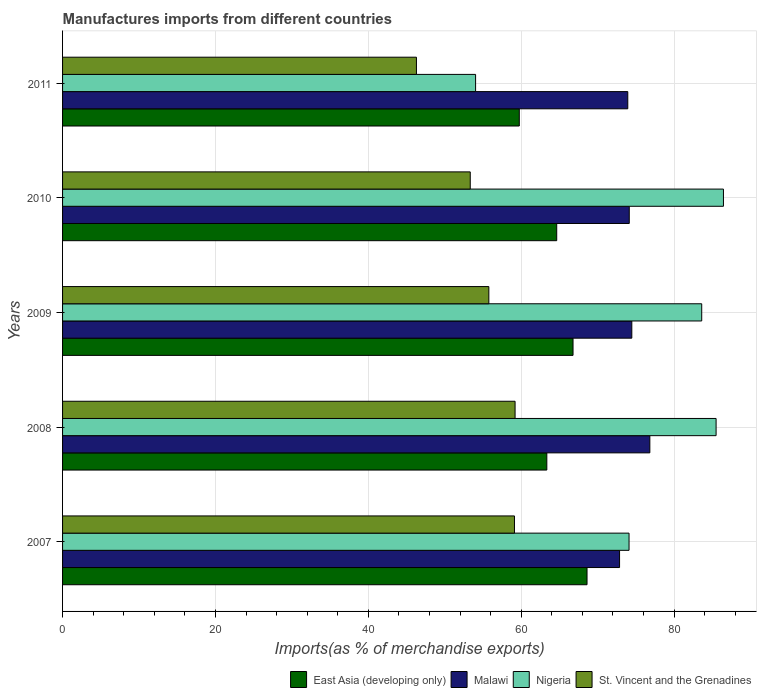Are the number of bars per tick equal to the number of legend labels?
Ensure brevity in your answer.  Yes. How many bars are there on the 2nd tick from the top?
Offer a very short reply. 4. How many bars are there on the 2nd tick from the bottom?
Provide a short and direct response. 4. What is the label of the 1st group of bars from the top?
Keep it short and to the point. 2011. In how many cases, is the number of bars for a given year not equal to the number of legend labels?
Provide a short and direct response. 0. What is the percentage of imports to different countries in Malawi in 2011?
Keep it short and to the point. 73.94. Across all years, what is the maximum percentage of imports to different countries in Nigeria?
Your answer should be very brief. 86.45. Across all years, what is the minimum percentage of imports to different countries in Malawi?
Your answer should be very brief. 72.86. In which year was the percentage of imports to different countries in St. Vincent and the Grenadines maximum?
Your response must be concise. 2008. In which year was the percentage of imports to different countries in East Asia (developing only) minimum?
Ensure brevity in your answer.  2011. What is the total percentage of imports to different countries in Malawi in the graph?
Your response must be concise. 372.21. What is the difference between the percentage of imports to different countries in Malawi in 2009 and that in 2011?
Provide a short and direct response. 0.53. What is the difference between the percentage of imports to different countries in Nigeria in 2010 and the percentage of imports to different countries in Malawi in 2007?
Ensure brevity in your answer.  13.59. What is the average percentage of imports to different countries in Malawi per year?
Provide a short and direct response. 74.44. In the year 2009, what is the difference between the percentage of imports to different countries in East Asia (developing only) and percentage of imports to different countries in Nigeria?
Make the answer very short. -16.83. In how many years, is the percentage of imports to different countries in East Asia (developing only) greater than 72 %?
Offer a very short reply. 0. What is the ratio of the percentage of imports to different countries in St. Vincent and the Grenadines in 2008 to that in 2010?
Make the answer very short. 1.11. Is the percentage of imports to different countries in East Asia (developing only) in 2007 less than that in 2011?
Provide a short and direct response. No. Is the difference between the percentage of imports to different countries in East Asia (developing only) in 2007 and 2008 greater than the difference between the percentage of imports to different countries in Nigeria in 2007 and 2008?
Offer a very short reply. Yes. What is the difference between the highest and the second highest percentage of imports to different countries in East Asia (developing only)?
Your response must be concise. 1.83. What is the difference between the highest and the lowest percentage of imports to different countries in Nigeria?
Make the answer very short. 32.42. Is the sum of the percentage of imports to different countries in East Asia (developing only) in 2008 and 2011 greater than the maximum percentage of imports to different countries in St. Vincent and the Grenadines across all years?
Your response must be concise. Yes. Is it the case that in every year, the sum of the percentage of imports to different countries in Malawi and percentage of imports to different countries in East Asia (developing only) is greater than the sum of percentage of imports to different countries in Nigeria and percentage of imports to different countries in St. Vincent and the Grenadines?
Offer a very short reply. No. What does the 1st bar from the top in 2010 represents?
Your answer should be very brief. St. Vincent and the Grenadines. What does the 1st bar from the bottom in 2011 represents?
Make the answer very short. East Asia (developing only). Is it the case that in every year, the sum of the percentage of imports to different countries in East Asia (developing only) and percentage of imports to different countries in Malawi is greater than the percentage of imports to different countries in Nigeria?
Offer a very short reply. Yes. Are all the bars in the graph horizontal?
Give a very brief answer. Yes. Are the values on the major ticks of X-axis written in scientific E-notation?
Provide a succinct answer. No. Does the graph contain any zero values?
Give a very brief answer. No. Does the graph contain grids?
Provide a succinct answer. Yes. How many legend labels are there?
Your response must be concise. 4. What is the title of the graph?
Your answer should be compact. Manufactures imports from different countries. Does "Croatia" appear as one of the legend labels in the graph?
Ensure brevity in your answer.  No. What is the label or title of the X-axis?
Your answer should be very brief. Imports(as % of merchandise exports). What is the label or title of the Y-axis?
Ensure brevity in your answer.  Years. What is the Imports(as % of merchandise exports) in East Asia (developing only) in 2007?
Provide a succinct answer. 68.6. What is the Imports(as % of merchandise exports) of Malawi in 2007?
Give a very brief answer. 72.86. What is the Imports(as % of merchandise exports) in Nigeria in 2007?
Offer a very short reply. 74.1. What is the Imports(as % of merchandise exports) in St. Vincent and the Grenadines in 2007?
Provide a short and direct response. 59.11. What is the Imports(as % of merchandise exports) in East Asia (developing only) in 2008?
Ensure brevity in your answer.  63.35. What is the Imports(as % of merchandise exports) of Malawi in 2008?
Ensure brevity in your answer.  76.82. What is the Imports(as % of merchandise exports) of Nigeria in 2008?
Your answer should be compact. 85.49. What is the Imports(as % of merchandise exports) in St. Vincent and the Grenadines in 2008?
Offer a terse response. 59.19. What is the Imports(as % of merchandise exports) in East Asia (developing only) in 2009?
Give a very brief answer. 66.77. What is the Imports(as % of merchandise exports) in Malawi in 2009?
Your answer should be compact. 74.46. What is the Imports(as % of merchandise exports) of Nigeria in 2009?
Offer a very short reply. 83.61. What is the Imports(as % of merchandise exports) in St. Vincent and the Grenadines in 2009?
Give a very brief answer. 55.76. What is the Imports(as % of merchandise exports) of East Asia (developing only) in 2010?
Keep it short and to the point. 64.64. What is the Imports(as % of merchandise exports) in Malawi in 2010?
Give a very brief answer. 74.13. What is the Imports(as % of merchandise exports) in Nigeria in 2010?
Offer a very short reply. 86.45. What is the Imports(as % of merchandise exports) of St. Vincent and the Grenadines in 2010?
Make the answer very short. 53.33. What is the Imports(as % of merchandise exports) in East Asia (developing only) in 2011?
Offer a terse response. 59.74. What is the Imports(as % of merchandise exports) in Malawi in 2011?
Give a very brief answer. 73.94. What is the Imports(as % of merchandise exports) of Nigeria in 2011?
Provide a short and direct response. 54.03. What is the Imports(as % of merchandise exports) of St. Vincent and the Grenadines in 2011?
Ensure brevity in your answer.  46.29. Across all years, what is the maximum Imports(as % of merchandise exports) of East Asia (developing only)?
Provide a short and direct response. 68.6. Across all years, what is the maximum Imports(as % of merchandise exports) of Malawi?
Provide a succinct answer. 76.82. Across all years, what is the maximum Imports(as % of merchandise exports) of Nigeria?
Keep it short and to the point. 86.45. Across all years, what is the maximum Imports(as % of merchandise exports) of St. Vincent and the Grenadines?
Offer a terse response. 59.19. Across all years, what is the minimum Imports(as % of merchandise exports) of East Asia (developing only)?
Make the answer very short. 59.74. Across all years, what is the minimum Imports(as % of merchandise exports) of Malawi?
Your answer should be compact. 72.86. Across all years, what is the minimum Imports(as % of merchandise exports) in Nigeria?
Give a very brief answer. 54.03. Across all years, what is the minimum Imports(as % of merchandise exports) in St. Vincent and the Grenadines?
Your response must be concise. 46.29. What is the total Imports(as % of merchandise exports) in East Asia (developing only) in the graph?
Your answer should be very brief. 323.11. What is the total Imports(as % of merchandise exports) in Malawi in the graph?
Give a very brief answer. 372.21. What is the total Imports(as % of merchandise exports) of Nigeria in the graph?
Ensure brevity in your answer.  383.67. What is the total Imports(as % of merchandise exports) of St. Vincent and the Grenadines in the graph?
Offer a very short reply. 273.69. What is the difference between the Imports(as % of merchandise exports) of East Asia (developing only) in 2007 and that in 2008?
Your answer should be compact. 5.26. What is the difference between the Imports(as % of merchandise exports) in Malawi in 2007 and that in 2008?
Your answer should be very brief. -3.96. What is the difference between the Imports(as % of merchandise exports) in Nigeria in 2007 and that in 2008?
Give a very brief answer. -11.39. What is the difference between the Imports(as % of merchandise exports) of St. Vincent and the Grenadines in 2007 and that in 2008?
Your answer should be compact. -0.08. What is the difference between the Imports(as % of merchandise exports) in East Asia (developing only) in 2007 and that in 2009?
Provide a succinct answer. 1.83. What is the difference between the Imports(as % of merchandise exports) of Malawi in 2007 and that in 2009?
Your answer should be compact. -1.6. What is the difference between the Imports(as % of merchandise exports) in Nigeria in 2007 and that in 2009?
Offer a very short reply. -9.51. What is the difference between the Imports(as % of merchandise exports) of St. Vincent and the Grenadines in 2007 and that in 2009?
Your answer should be very brief. 3.35. What is the difference between the Imports(as % of merchandise exports) of East Asia (developing only) in 2007 and that in 2010?
Your answer should be compact. 3.96. What is the difference between the Imports(as % of merchandise exports) of Malawi in 2007 and that in 2010?
Your answer should be very brief. -1.27. What is the difference between the Imports(as % of merchandise exports) of Nigeria in 2007 and that in 2010?
Keep it short and to the point. -12.35. What is the difference between the Imports(as % of merchandise exports) of St. Vincent and the Grenadines in 2007 and that in 2010?
Offer a very short reply. 5.78. What is the difference between the Imports(as % of merchandise exports) of East Asia (developing only) in 2007 and that in 2011?
Provide a succinct answer. 8.86. What is the difference between the Imports(as % of merchandise exports) in Malawi in 2007 and that in 2011?
Make the answer very short. -1.08. What is the difference between the Imports(as % of merchandise exports) of Nigeria in 2007 and that in 2011?
Your response must be concise. 20.07. What is the difference between the Imports(as % of merchandise exports) in St. Vincent and the Grenadines in 2007 and that in 2011?
Your response must be concise. 12.82. What is the difference between the Imports(as % of merchandise exports) in East Asia (developing only) in 2008 and that in 2009?
Give a very brief answer. -3.43. What is the difference between the Imports(as % of merchandise exports) of Malawi in 2008 and that in 2009?
Your answer should be very brief. 2.36. What is the difference between the Imports(as % of merchandise exports) in Nigeria in 2008 and that in 2009?
Your answer should be very brief. 1.88. What is the difference between the Imports(as % of merchandise exports) of St. Vincent and the Grenadines in 2008 and that in 2009?
Ensure brevity in your answer.  3.43. What is the difference between the Imports(as % of merchandise exports) in East Asia (developing only) in 2008 and that in 2010?
Offer a terse response. -1.29. What is the difference between the Imports(as % of merchandise exports) in Malawi in 2008 and that in 2010?
Your response must be concise. 2.69. What is the difference between the Imports(as % of merchandise exports) of Nigeria in 2008 and that in 2010?
Offer a very short reply. -0.96. What is the difference between the Imports(as % of merchandise exports) in St. Vincent and the Grenadines in 2008 and that in 2010?
Provide a short and direct response. 5.86. What is the difference between the Imports(as % of merchandise exports) of East Asia (developing only) in 2008 and that in 2011?
Provide a short and direct response. 3.6. What is the difference between the Imports(as % of merchandise exports) in Malawi in 2008 and that in 2011?
Your response must be concise. 2.89. What is the difference between the Imports(as % of merchandise exports) in Nigeria in 2008 and that in 2011?
Make the answer very short. 31.46. What is the difference between the Imports(as % of merchandise exports) of St. Vincent and the Grenadines in 2008 and that in 2011?
Provide a short and direct response. 12.9. What is the difference between the Imports(as % of merchandise exports) of East Asia (developing only) in 2009 and that in 2010?
Ensure brevity in your answer.  2.13. What is the difference between the Imports(as % of merchandise exports) of Malawi in 2009 and that in 2010?
Make the answer very short. 0.33. What is the difference between the Imports(as % of merchandise exports) in Nigeria in 2009 and that in 2010?
Give a very brief answer. -2.84. What is the difference between the Imports(as % of merchandise exports) in St. Vincent and the Grenadines in 2009 and that in 2010?
Ensure brevity in your answer.  2.43. What is the difference between the Imports(as % of merchandise exports) in East Asia (developing only) in 2009 and that in 2011?
Your answer should be compact. 7.03. What is the difference between the Imports(as % of merchandise exports) of Malawi in 2009 and that in 2011?
Offer a very short reply. 0.53. What is the difference between the Imports(as % of merchandise exports) of Nigeria in 2009 and that in 2011?
Keep it short and to the point. 29.58. What is the difference between the Imports(as % of merchandise exports) in St. Vincent and the Grenadines in 2009 and that in 2011?
Keep it short and to the point. 9.47. What is the difference between the Imports(as % of merchandise exports) of East Asia (developing only) in 2010 and that in 2011?
Your answer should be compact. 4.9. What is the difference between the Imports(as % of merchandise exports) in Malawi in 2010 and that in 2011?
Offer a terse response. 0.19. What is the difference between the Imports(as % of merchandise exports) of Nigeria in 2010 and that in 2011?
Offer a terse response. 32.42. What is the difference between the Imports(as % of merchandise exports) of St. Vincent and the Grenadines in 2010 and that in 2011?
Your answer should be compact. 7.04. What is the difference between the Imports(as % of merchandise exports) in East Asia (developing only) in 2007 and the Imports(as % of merchandise exports) in Malawi in 2008?
Keep it short and to the point. -8.22. What is the difference between the Imports(as % of merchandise exports) of East Asia (developing only) in 2007 and the Imports(as % of merchandise exports) of Nigeria in 2008?
Give a very brief answer. -16.88. What is the difference between the Imports(as % of merchandise exports) in East Asia (developing only) in 2007 and the Imports(as % of merchandise exports) in St. Vincent and the Grenadines in 2008?
Your response must be concise. 9.41. What is the difference between the Imports(as % of merchandise exports) of Malawi in 2007 and the Imports(as % of merchandise exports) of Nigeria in 2008?
Keep it short and to the point. -12.63. What is the difference between the Imports(as % of merchandise exports) in Malawi in 2007 and the Imports(as % of merchandise exports) in St. Vincent and the Grenadines in 2008?
Make the answer very short. 13.67. What is the difference between the Imports(as % of merchandise exports) of Nigeria in 2007 and the Imports(as % of merchandise exports) of St. Vincent and the Grenadines in 2008?
Give a very brief answer. 14.91. What is the difference between the Imports(as % of merchandise exports) in East Asia (developing only) in 2007 and the Imports(as % of merchandise exports) in Malawi in 2009?
Your answer should be compact. -5.86. What is the difference between the Imports(as % of merchandise exports) in East Asia (developing only) in 2007 and the Imports(as % of merchandise exports) in Nigeria in 2009?
Give a very brief answer. -15. What is the difference between the Imports(as % of merchandise exports) in East Asia (developing only) in 2007 and the Imports(as % of merchandise exports) in St. Vincent and the Grenadines in 2009?
Give a very brief answer. 12.84. What is the difference between the Imports(as % of merchandise exports) in Malawi in 2007 and the Imports(as % of merchandise exports) in Nigeria in 2009?
Make the answer very short. -10.75. What is the difference between the Imports(as % of merchandise exports) in Malawi in 2007 and the Imports(as % of merchandise exports) in St. Vincent and the Grenadines in 2009?
Provide a short and direct response. 17.1. What is the difference between the Imports(as % of merchandise exports) of Nigeria in 2007 and the Imports(as % of merchandise exports) of St. Vincent and the Grenadines in 2009?
Ensure brevity in your answer.  18.34. What is the difference between the Imports(as % of merchandise exports) in East Asia (developing only) in 2007 and the Imports(as % of merchandise exports) in Malawi in 2010?
Provide a short and direct response. -5.52. What is the difference between the Imports(as % of merchandise exports) in East Asia (developing only) in 2007 and the Imports(as % of merchandise exports) in Nigeria in 2010?
Your response must be concise. -17.85. What is the difference between the Imports(as % of merchandise exports) in East Asia (developing only) in 2007 and the Imports(as % of merchandise exports) in St. Vincent and the Grenadines in 2010?
Provide a short and direct response. 15.28. What is the difference between the Imports(as % of merchandise exports) in Malawi in 2007 and the Imports(as % of merchandise exports) in Nigeria in 2010?
Offer a terse response. -13.59. What is the difference between the Imports(as % of merchandise exports) in Malawi in 2007 and the Imports(as % of merchandise exports) in St. Vincent and the Grenadines in 2010?
Offer a terse response. 19.53. What is the difference between the Imports(as % of merchandise exports) in Nigeria in 2007 and the Imports(as % of merchandise exports) in St. Vincent and the Grenadines in 2010?
Your response must be concise. 20.77. What is the difference between the Imports(as % of merchandise exports) of East Asia (developing only) in 2007 and the Imports(as % of merchandise exports) of Malawi in 2011?
Your answer should be compact. -5.33. What is the difference between the Imports(as % of merchandise exports) of East Asia (developing only) in 2007 and the Imports(as % of merchandise exports) of Nigeria in 2011?
Your answer should be very brief. 14.58. What is the difference between the Imports(as % of merchandise exports) of East Asia (developing only) in 2007 and the Imports(as % of merchandise exports) of St. Vincent and the Grenadines in 2011?
Provide a short and direct response. 22.31. What is the difference between the Imports(as % of merchandise exports) of Malawi in 2007 and the Imports(as % of merchandise exports) of Nigeria in 2011?
Provide a short and direct response. 18.83. What is the difference between the Imports(as % of merchandise exports) of Malawi in 2007 and the Imports(as % of merchandise exports) of St. Vincent and the Grenadines in 2011?
Make the answer very short. 26.57. What is the difference between the Imports(as % of merchandise exports) of Nigeria in 2007 and the Imports(as % of merchandise exports) of St. Vincent and the Grenadines in 2011?
Keep it short and to the point. 27.81. What is the difference between the Imports(as % of merchandise exports) in East Asia (developing only) in 2008 and the Imports(as % of merchandise exports) in Malawi in 2009?
Your response must be concise. -11.12. What is the difference between the Imports(as % of merchandise exports) of East Asia (developing only) in 2008 and the Imports(as % of merchandise exports) of Nigeria in 2009?
Make the answer very short. -20.26. What is the difference between the Imports(as % of merchandise exports) of East Asia (developing only) in 2008 and the Imports(as % of merchandise exports) of St. Vincent and the Grenadines in 2009?
Ensure brevity in your answer.  7.58. What is the difference between the Imports(as % of merchandise exports) in Malawi in 2008 and the Imports(as % of merchandise exports) in Nigeria in 2009?
Your answer should be compact. -6.78. What is the difference between the Imports(as % of merchandise exports) of Malawi in 2008 and the Imports(as % of merchandise exports) of St. Vincent and the Grenadines in 2009?
Provide a short and direct response. 21.06. What is the difference between the Imports(as % of merchandise exports) of Nigeria in 2008 and the Imports(as % of merchandise exports) of St. Vincent and the Grenadines in 2009?
Provide a short and direct response. 29.73. What is the difference between the Imports(as % of merchandise exports) in East Asia (developing only) in 2008 and the Imports(as % of merchandise exports) in Malawi in 2010?
Offer a terse response. -10.78. What is the difference between the Imports(as % of merchandise exports) in East Asia (developing only) in 2008 and the Imports(as % of merchandise exports) in Nigeria in 2010?
Keep it short and to the point. -23.1. What is the difference between the Imports(as % of merchandise exports) in East Asia (developing only) in 2008 and the Imports(as % of merchandise exports) in St. Vincent and the Grenadines in 2010?
Your answer should be compact. 10.02. What is the difference between the Imports(as % of merchandise exports) of Malawi in 2008 and the Imports(as % of merchandise exports) of Nigeria in 2010?
Ensure brevity in your answer.  -9.63. What is the difference between the Imports(as % of merchandise exports) in Malawi in 2008 and the Imports(as % of merchandise exports) in St. Vincent and the Grenadines in 2010?
Your answer should be very brief. 23.49. What is the difference between the Imports(as % of merchandise exports) of Nigeria in 2008 and the Imports(as % of merchandise exports) of St. Vincent and the Grenadines in 2010?
Give a very brief answer. 32.16. What is the difference between the Imports(as % of merchandise exports) of East Asia (developing only) in 2008 and the Imports(as % of merchandise exports) of Malawi in 2011?
Offer a very short reply. -10.59. What is the difference between the Imports(as % of merchandise exports) in East Asia (developing only) in 2008 and the Imports(as % of merchandise exports) in Nigeria in 2011?
Offer a terse response. 9.32. What is the difference between the Imports(as % of merchandise exports) in East Asia (developing only) in 2008 and the Imports(as % of merchandise exports) in St. Vincent and the Grenadines in 2011?
Give a very brief answer. 17.06. What is the difference between the Imports(as % of merchandise exports) in Malawi in 2008 and the Imports(as % of merchandise exports) in Nigeria in 2011?
Make the answer very short. 22.79. What is the difference between the Imports(as % of merchandise exports) of Malawi in 2008 and the Imports(as % of merchandise exports) of St. Vincent and the Grenadines in 2011?
Provide a succinct answer. 30.53. What is the difference between the Imports(as % of merchandise exports) in Nigeria in 2008 and the Imports(as % of merchandise exports) in St. Vincent and the Grenadines in 2011?
Your answer should be very brief. 39.2. What is the difference between the Imports(as % of merchandise exports) of East Asia (developing only) in 2009 and the Imports(as % of merchandise exports) of Malawi in 2010?
Give a very brief answer. -7.35. What is the difference between the Imports(as % of merchandise exports) of East Asia (developing only) in 2009 and the Imports(as % of merchandise exports) of Nigeria in 2010?
Provide a succinct answer. -19.68. What is the difference between the Imports(as % of merchandise exports) in East Asia (developing only) in 2009 and the Imports(as % of merchandise exports) in St. Vincent and the Grenadines in 2010?
Ensure brevity in your answer.  13.45. What is the difference between the Imports(as % of merchandise exports) of Malawi in 2009 and the Imports(as % of merchandise exports) of Nigeria in 2010?
Provide a short and direct response. -11.99. What is the difference between the Imports(as % of merchandise exports) in Malawi in 2009 and the Imports(as % of merchandise exports) in St. Vincent and the Grenadines in 2010?
Offer a very short reply. 21.13. What is the difference between the Imports(as % of merchandise exports) of Nigeria in 2009 and the Imports(as % of merchandise exports) of St. Vincent and the Grenadines in 2010?
Keep it short and to the point. 30.28. What is the difference between the Imports(as % of merchandise exports) in East Asia (developing only) in 2009 and the Imports(as % of merchandise exports) in Malawi in 2011?
Offer a very short reply. -7.16. What is the difference between the Imports(as % of merchandise exports) of East Asia (developing only) in 2009 and the Imports(as % of merchandise exports) of Nigeria in 2011?
Make the answer very short. 12.75. What is the difference between the Imports(as % of merchandise exports) of East Asia (developing only) in 2009 and the Imports(as % of merchandise exports) of St. Vincent and the Grenadines in 2011?
Give a very brief answer. 20.48. What is the difference between the Imports(as % of merchandise exports) in Malawi in 2009 and the Imports(as % of merchandise exports) in Nigeria in 2011?
Your answer should be compact. 20.43. What is the difference between the Imports(as % of merchandise exports) of Malawi in 2009 and the Imports(as % of merchandise exports) of St. Vincent and the Grenadines in 2011?
Your response must be concise. 28.17. What is the difference between the Imports(as % of merchandise exports) of Nigeria in 2009 and the Imports(as % of merchandise exports) of St. Vincent and the Grenadines in 2011?
Provide a short and direct response. 37.32. What is the difference between the Imports(as % of merchandise exports) in East Asia (developing only) in 2010 and the Imports(as % of merchandise exports) in Malawi in 2011?
Your response must be concise. -9.3. What is the difference between the Imports(as % of merchandise exports) in East Asia (developing only) in 2010 and the Imports(as % of merchandise exports) in Nigeria in 2011?
Ensure brevity in your answer.  10.61. What is the difference between the Imports(as % of merchandise exports) of East Asia (developing only) in 2010 and the Imports(as % of merchandise exports) of St. Vincent and the Grenadines in 2011?
Offer a terse response. 18.35. What is the difference between the Imports(as % of merchandise exports) of Malawi in 2010 and the Imports(as % of merchandise exports) of Nigeria in 2011?
Provide a succinct answer. 20.1. What is the difference between the Imports(as % of merchandise exports) of Malawi in 2010 and the Imports(as % of merchandise exports) of St. Vincent and the Grenadines in 2011?
Give a very brief answer. 27.84. What is the difference between the Imports(as % of merchandise exports) in Nigeria in 2010 and the Imports(as % of merchandise exports) in St. Vincent and the Grenadines in 2011?
Your response must be concise. 40.16. What is the average Imports(as % of merchandise exports) of East Asia (developing only) per year?
Provide a short and direct response. 64.62. What is the average Imports(as % of merchandise exports) in Malawi per year?
Offer a terse response. 74.44. What is the average Imports(as % of merchandise exports) of Nigeria per year?
Provide a short and direct response. 76.73. What is the average Imports(as % of merchandise exports) of St. Vincent and the Grenadines per year?
Ensure brevity in your answer.  54.74. In the year 2007, what is the difference between the Imports(as % of merchandise exports) in East Asia (developing only) and Imports(as % of merchandise exports) in Malawi?
Make the answer very short. -4.26. In the year 2007, what is the difference between the Imports(as % of merchandise exports) in East Asia (developing only) and Imports(as % of merchandise exports) in Nigeria?
Keep it short and to the point. -5.5. In the year 2007, what is the difference between the Imports(as % of merchandise exports) in East Asia (developing only) and Imports(as % of merchandise exports) in St. Vincent and the Grenadines?
Your response must be concise. 9.49. In the year 2007, what is the difference between the Imports(as % of merchandise exports) in Malawi and Imports(as % of merchandise exports) in Nigeria?
Your response must be concise. -1.24. In the year 2007, what is the difference between the Imports(as % of merchandise exports) in Malawi and Imports(as % of merchandise exports) in St. Vincent and the Grenadines?
Keep it short and to the point. 13.75. In the year 2007, what is the difference between the Imports(as % of merchandise exports) in Nigeria and Imports(as % of merchandise exports) in St. Vincent and the Grenadines?
Make the answer very short. 14.99. In the year 2008, what is the difference between the Imports(as % of merchandise exports) of East Asia (developing only) and Imports(as % of merchandise exports) of Malawi?
Provide a short and direct response. -13.48. In the year 2008, what is the difference between the Imports(as % of merchandise exports) in East Asia (developing only) and Imports(as % of merchandise exports) in Nigeria?
Offer a very short reply. -22.14. In the year 2008, what is the difference between the Imports(as % of merchandise exports) in East Asia (developing only) and Imports(as % of merchandise exports) in St. Vincent and the Grenadines?
Your answer should be compact. 4.15. In the year 2008, what is the difference between the Imports(as % of merchandise exports) of Malawi and Imports(as % of merchandise exports) of Nigeria?
Your answer should be very brief. -8.67. In the year 2008, what is the difference between the Imports(as % of merchandise exports) in Malawi and Imports(as % of merchandise exports) in St. Vincent and the Grenadines?
Offer a terse response. 17.63. In the year 2008, what is the difference between the Imports(as % of merchandise exports) of Nigeria and Imports(as % of merchandise exports) of St. Vincent and the Grenadines?
Keep it short and to the point. 26.29. In the year 2009, what is the difference between the Imports(as % of merchandise exports) in East Asia (developing only) and Imports(as % of merchandise exports) in Malawi?
Your answer should be very brief. -7.69. In the year 2009, what is the difference between the Imports(as % of merchandise exports) of East Asia (developing only) and Imports(as % of merchandise exports) of Nigeria?
Your response must be concise. -16.83. In the year 2009, what is the difference between the Imports(as % of merchandise exports) in East Asia (developing only) and Imports(as % of merchandise exports) in St. Vincent and the Grenadines?
Ensure brevity in your answer.  11.01. In the year 2009, what is the difference between the Imports(as % of merchandise exports) in Malawi and Imports(as % of merchandise exports) in Nigeria?
Provide a short and direct response. -9.14. In the year 2009, what is the difference between the Imports(as % of merchandise exports) of Malawi and Imports(as % of merchandise exports) of St. Vincent and the Grenadines?
Give a very brief answer. 18.7. In the year 2009, what is the difference between the Imports(as % of merchandise exports) in Nigeria and Imports(as % of merchandise exports) in St. Vincent and the Grenadines?
Your answer should be compact. 27.85. In the year 2010, what is the difference between the Imports(as % of merchandise exports) in East Asia (developing only) and Imports(as % of merchandise exports) in Malawi?
Your response must be concise. -9.49. In the year 2010, what is the difference between the Imports(as % of merchandise exports) in East Asia (developing only) and Imports(as % of merchandise exports) in Nigeria?
Your answer should be compact. -21.81. In the year 2010, what is the difference between the Imports(as % of merchandise exports) in East Asia (developing only) and Imports(as % of merchandise exports) in St. Vincent and the Grenadines?
Provide a short and direct response. 11.31. In the year 2010, what is the difference between the Imports(as % of merchandise exports) in Malawi and Imports(as % of merchandise exports) in Nigeria?
Provide a succinct answer. -12.32. In the year 2010, what is the difference between the Imports(as % of merchandise exports) of Malawi and Imports(as % of merchandise exports) of St. Vincent and the Grenadines?
Offer a terse response. 20.8. In the year 2010, what is the difference between the Imports(as % of merchandise exports) in Nigeria and Imports(as % of merchandise exports) in St. Vincent and the Grenadines?
Provide a succinct answer. 33.12. In the year 2011, what is the difference between the Imports(as % of merchandise exports) in East Asia (developing only) and Imports(as % of merchandise exports) in Malawi?
Offer a very short reply. -14.19. In the year 2011, what is the difference between the Imports(as % of merchandise exports) of East Asia (developing only) and Imports(as % of merchandise exports) of Nigeria?
Ensure brevity in your answer.  5.72. In the year 2011, what is the difference between the Imports(as % of merchandise exports) of East Asia (developing only) and Imports(as % of merchandise exports) of St. Vincent and the Grenadines?
Keep it short and to the point. 13.45. In the year 2011, what is the difference between the Imports(as % of merchandise exports) of Malawi and Imports(as % of merchandise exports) of Nigeria?
Keep it short and to the point. 19.91. In the year 2011, what is the difference between the Imports(as % of merchandise exports) in Malawi and Imports(as % of merchandise exports) in St. Vincent and the Grenadines?
Offer a terse response. 27.65. In the year 2011, what is the difference between the Imports(as % of merchandise exports) of Nigeria and Imports(as % of merchandise exports) of St. Vincent and the Grenadines?
Your answer should be compact. 7.74. What is the ratio of the Imports(as % of merchandise exports) of East Asia (developing only) in 2007 to that in 2008?
Make the answer very short. 1.08. What is the ratio of the Imports(as % of merchandise exports) of Malawi in 2007 to that in 2008?
Your response must be concise. 0.95. What is the ratio of the Imports(as % of merchandise exports) in Nigeria in 2007 to that in 2008?
Offer a terse response. 0.87. What is the ratio of the Imports(as % of merchandise exports) in St. Vincent and the Grenadines in 2007 to that in 2008?
Provide a succinct answer. 1. What is the ratio of the Imports(as % of merchandise exports) in East Asia (developing only) in 2007 to that in 2009?
Provide a succinct answer. 1.03. What is the ratio of the Imports(as % of merchandise exports) of Malawi in 2007 to that in 2009?
Your answer should be compact. 0.98. What is the ratio of the Imports(as % of merchandise exports) in Nigeria in 2007 to that in 2009?
Your answer should be compact. 0.89. What is the ratio of the Imports(as % of merchandise exports) in St. Vincent and the Grenadines in 2007 to that in 2009?
Provide a short and direct response. 1.06. What is the ratio of the Imports(as % of merchandise exports) in East Asia (developing only) in 2007 to that in 2010?
Your answer should be very brief. 1.06. What is the ratio of the Imports(as % of merchandise exports) of Malawi in 2007 to that in 2010?
Your answer should be very brief. 0.98. What is the ratio of the Imports(as % of merchandise exports) of Nigeria in 2007 to that in 2010?
Offer a terse response. 0.86. What is the ratio of the Imports(as % of merchandise exports) of St. Vincent and the Grenadines in 2007 to that in 2010?
Provide a short and direct response. 1.11. What is the ratio of the Imports(as % of merchandise exports) of East Asia (developing only) in 2007 to that in 2011?
Keep it short and to the point. 1.15. What is the ratio of the Imports(as % of merchandise exports) of Malawi in 2007 to that in 2011?
Your response must be concise. 0.99. What is the ratio of the Imports(as % of merchandise exports) of Nigeria in 2007 to that in 2011?
Give a very brief answer. 1.37. What is the ratio of the Imports(as % of merchandise exports) of St. Vincent and the Grenadines in 2007 to that in 2011?
Give a very brief answer. 1.28. What is the ratio of the Imports(as % of merchandise exports) in East Asia (developing only) in 2008 to that in 2009?
Give a very brief answer. 0.95. What is the ratio of the Imports(as % of merchandise exports) in Malawi in 2008 to that in 2009?
Give a very brief answer. 1.03. What is the ratio of the Imports(as % of merchandise exports) in Nigeria in 2008 to that in 2009?
Offer a terse response. 1.02. What is the ratio of the Imports(as % of merchandise exports) of St. Vincent and the Grenadines in 2008 to that in 2009?
Ensure brevity in your answer.  1.06. What is the ratio of the Imports(as % of merchandise exports) of East Asia (developing only) in 2008 to that in 2010?
Your answer should be compact. 0.98. What is the ratio of the Imports(as % of merchandise exports) in Malawi in 2008 to that in 2010?
Your response must be concise. 1.04. What is the ratio of the Imports(as % of merchandise exports) in Nigeria in 2008 to that in 2010?
Your response must be concise. 0.99. What is the ratio of the Imports(as % of merchandise exports) of St. Vincent and the Grenadines in 2008 to that in 2010?
Provide a succinct answer. 1.11. What is the ratio of the Imports(as % of merchandise exports) of East Asia (developing only) in 2008 to that in 2011?
Offer a very short reply. 1.06. What is the ratio of the Imports(as % of merchandise exports) in Malawi in 2008 to that in 2011?
Keep it short and to the point. 1.04. What is the ratio of the Imports(as % of merchandise exports) in Nigeria in 2008 to that in 2011?
Make the answer very short. 1.58. What is the ratio of the Imports(as % of merchandise exports) in St. Vincent and the Grenadines in 2008 to that in 2011?
Keep it short and to the point. 1.28. What is the ratio of the Imports(as % of merchandise exports) of East Asia (developing only) in 2009 to that in 2010?
Keep it short and to the point. 1.03. What is the ratio of the Imports(as % of merchandise exports) in Nigeria in 2009 to that in 2010?
Offer a very short reply. 0.97. What is the ratio of the Imports(as % of merchandise exports) of St. Vincent and the Grenadines in 2009 to that in 2010?
Your answer should be compact. 1.05. What is the ratio of the Imports(as % of merchandise exports) in East Asia (developing only) in 2009 to that in 2011?
Make the answer very short. 1.12. What is the ratio of the Imports(as % of merchandise exports) of Malawi in 2009 to that in 2011?
Your response must be concise. 1.01. What is the ratio of the Imports(as % of merchandise exports) of Nigeria in 2009 to that in 2011?
Keep it short and to the point. 1.55. What is the ratio of the Imports(as % of merchandise exports) in St. Vincent and the Grenadines in 2009 to that in 2011?
Provide a short and direct response. 1.2. What is the ratio of the Imports(as % of merchandise exports) of East Asia (developing only) in 2010 to that in 2011?
Your answer should be compact. 1.08. What is the ratio of the Imports(as % of merchandise exports) of Malawi in 2010 to that in 2011?
Provide a succinct answer. 1. What is the ratio of the Imports(as % of merchandise exports) in Nigeria in 2010 to that in 2011?
Make the answer very short. 1.6. What is the ratio of the Imports(as % of merchandise exports) of St. Vincent and the Grenadines in 2010 to that in 2011?
Make the answer very short. 1.15. What is the difference between the highest and the second highest Imports(as % of merchandise exports) in East Asia (developing only)?
Your answer should be compact. 1.83. What is the difference between the highest and the second highest Imports(as % of merchandise exports) of Malawi?
Give a very brief answer. 2.36. What is the difference between the highest and the second highest Imports(as % of merchandise exports) in Nigeria?
Provide a succinct answer. 0.96. What is the difference between the highest and the second highest Imports(as % of merchandise exports) of St. Vincent and the Grenadines?
Keep it short and to the point. 0.08. What is the difference between the highest and the lowest Imports(as % of merchandise exports) of East Asia (developing only)?
Offer a very short reply. 8.86. What is the difference between the highest and the lowest Imports(as % of merchandise exports) of Malawi?
Ensure brevity in your answer.  3.96. What is the difference between the highest and the lowest Imports(as % of merchandise exports) of Nigeria?
Give a very brief answer. 32.42. What is the difference between the highest and the lowest Imports(as % of merchandise exports) in St. Vincent and the Grenadines?
Offer a terse response. 12.9. 